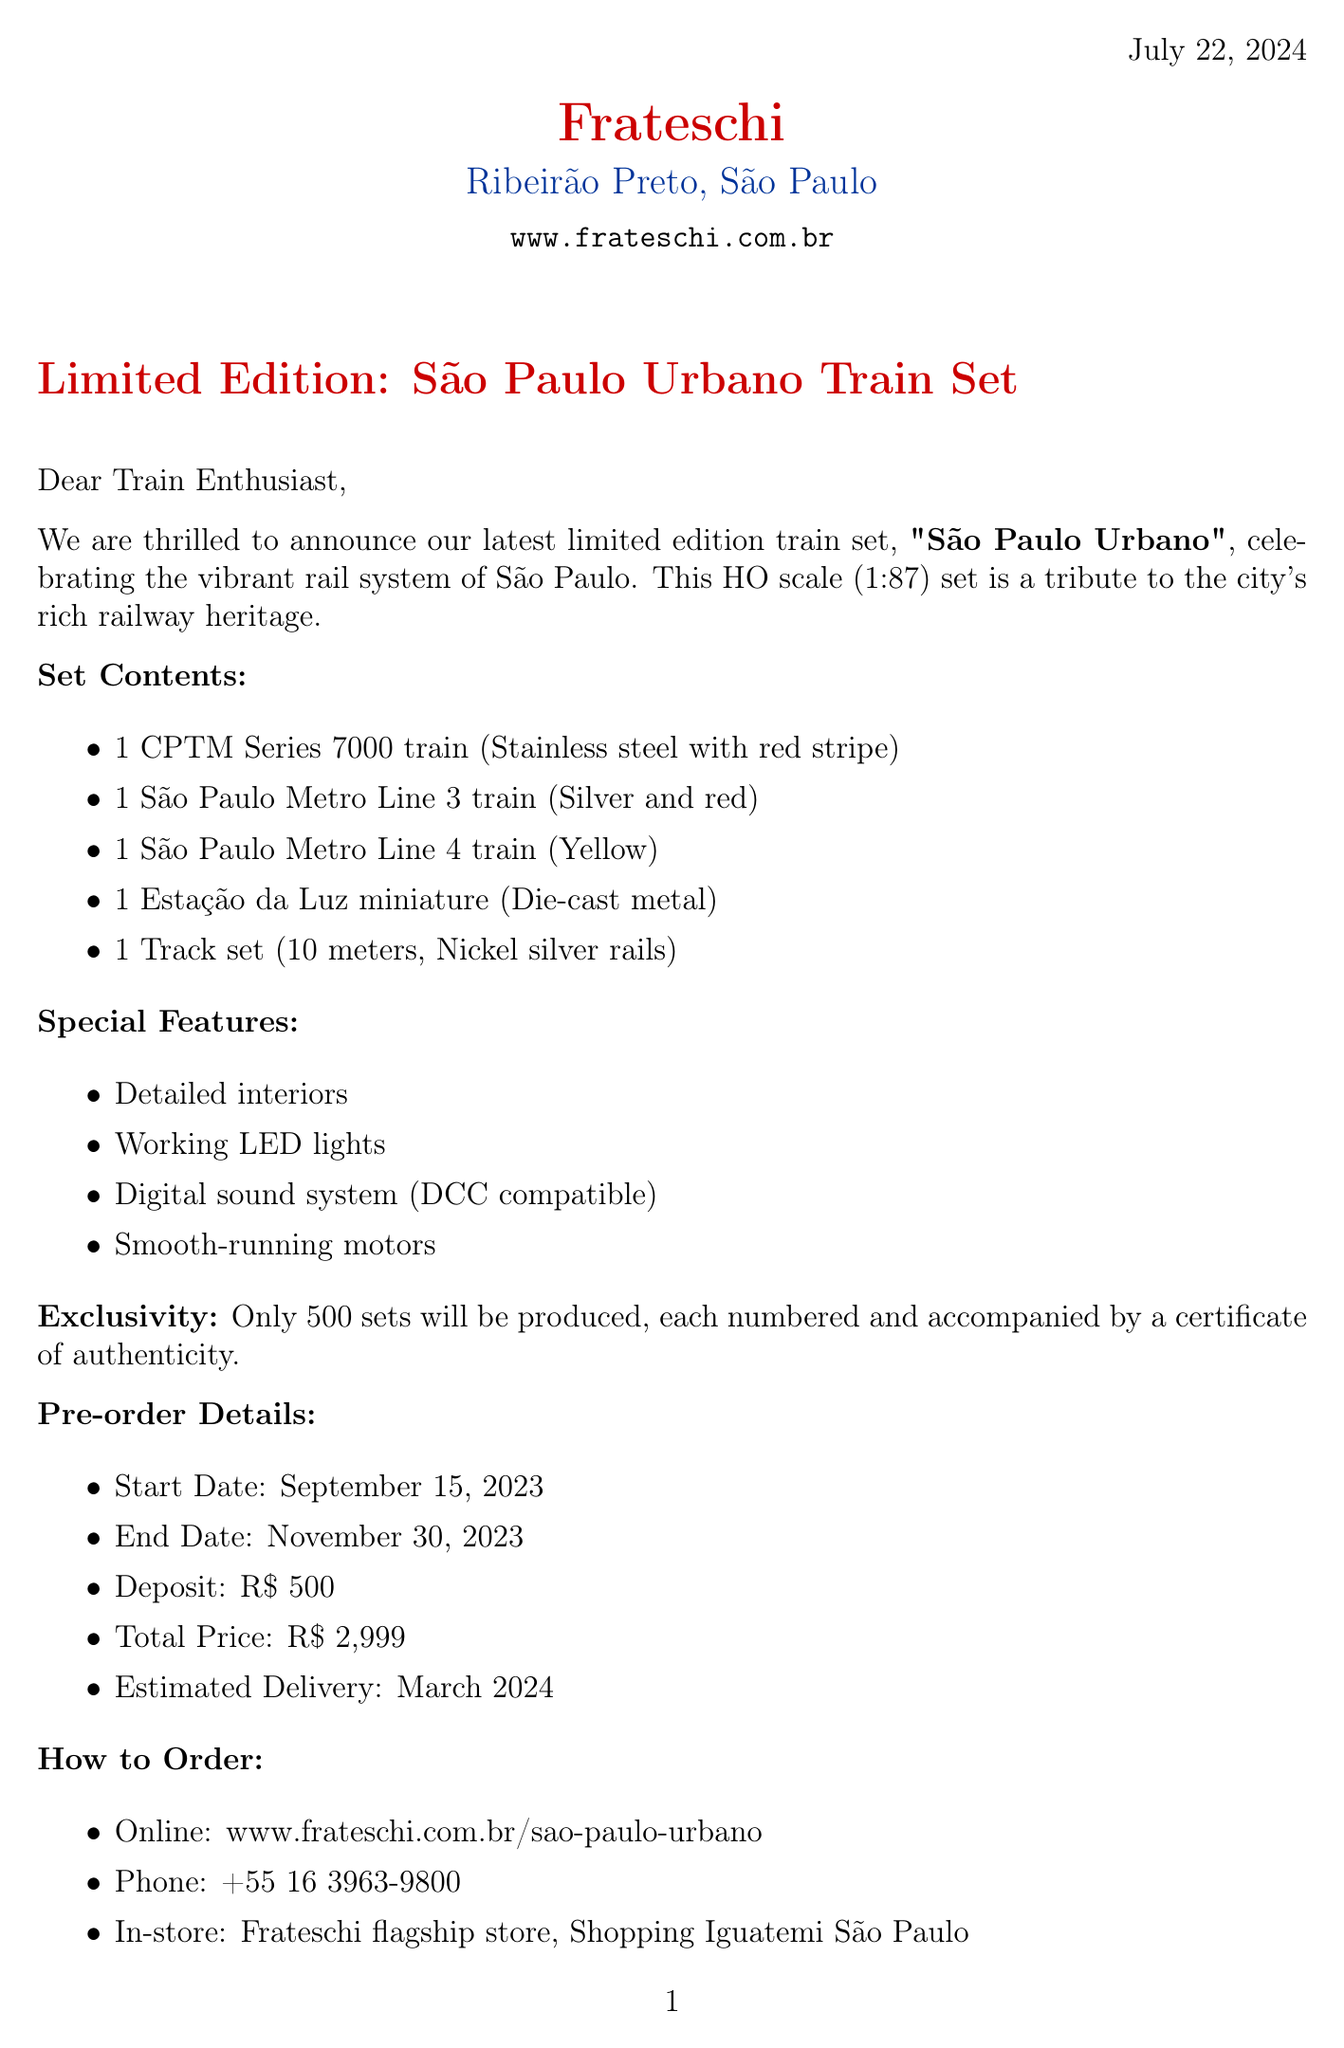What is the scale of the train set? The scale of the train set is mentioned as HO (1:87) in the document.
Answer: HO (1:87) How many pieces are included in the set? The document states that the set contains 5 pieces.
Answer: 5 What is the total price for the train set? The total price is specified in the document as R$ 2,999.
Answer: R$ 2,999 When does the pre-order period end? The document clearly indicates that the pre-order period ends on November 30, 2023.
Answer: November 30, 2023 Who is the designer of the train set? The designer's name is provided in the document as Roberto Coelho.
Answer: Roberto Coelho How many limited edition sets will be produced? The document states that only 500 sets will be produced for this limited edition.
Answer: 500 What is special about the packaging? The document describes the packaging as a collector's wooden box with São Paulo skyline engraving.
Answer: Collector's wooden box with São Paulo skyline engraving What type of customer support is mentioned? The document includes various forms of customer support, such as email and phone contact.
Answer: Email and phone support 